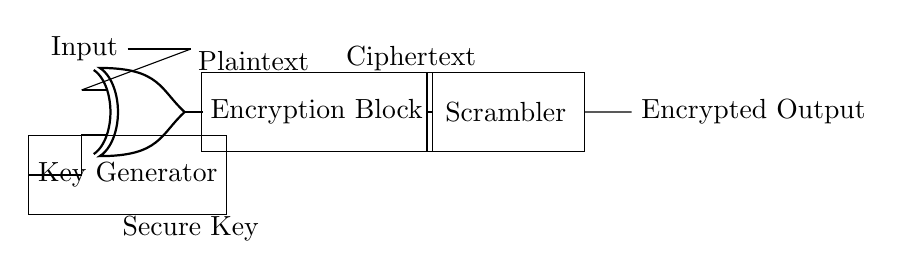What component is used for encryption in this circuit? The component used for encryption is the Encryption Block, which takes the output from the XOR gate and processes it to create ciphertext.
Answer: Encryption Block What type of gate is represented in the circuit? The circuit includes an XOR gate, which is indicated by the symbol seen in the diagram. This gate performs a logical exclusive OR operation.
Answer: XOR What is the output of the scrambler? The output of the scrambler is labeled as Encrypted Output, meaning it produces the final encrypted data for secure communication.
Answer: Encrypted Output How many main functional blocks are present in the circuit? There are three main functional blocks in the circuit: Key Generator, Encryption Block, and Scrambler. Each plays a critical role in the encryption process.
Answer: Three What is the input label provided in the circuit? The diagram labels the input as Plaintext, indicating the unencrypted data that will undergo the encryption process.
Answer: Plaintext What is the purpose of the key generator in this circuit? The key generator's purpose is to provide a secure key to the XOR gate, enabling it to function correctly and perform the encryption of the plaintext.
Answer: Secure Key 